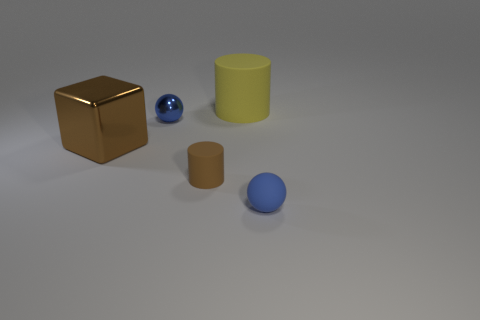There is a ball that is the same material as the large block; what is its color?
Your answer should be compact. Blue. How many small objects have the same material as the yellow cylinder?
Offer a very short reply. 2. Do the cylinder that is behind the big brown object and the blue object behind the small brown cylinder have the same size?
Make the answer very short. No. What is the material of the brown object that is to the left of the sphere that is behind the large brown block?
Offer a terse response. Metal. Are there fewer large yellow rubber objects to the left of the big block than yellow rubber things behind the metallic ball?
Provide a succinct answer. Yes. There is a small object that is the same color as the metal block; what material is it?
Give a very brief answer. Rubber. Is there any other thing that has the same shape as the blue rubber thing?
Offer a very short reply. Yes. There is a small sphere that is to the right of the tiny metallic ball; what is its material?
Provide a short and direct response. Rubber. Are there any other things that are the same size as the brown metal cube?
Your response must be concise. Yes. There is a large metal block; are there any tiny matte things behind it?
Your answer should be very brief. No. 